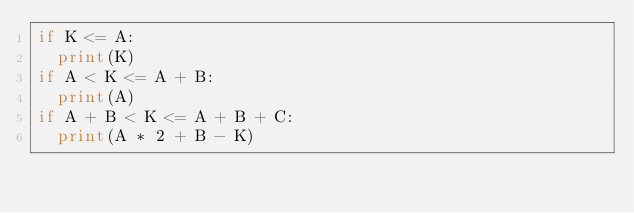<code> <loc_0><loc_0><loc_500><loc_500><_Python_>if K <= A:
  print(K)
if A < K <= A + B:
  print(A)
if A + B < K <= A + B + C:
  print(A * 2 + B - K)</code> 